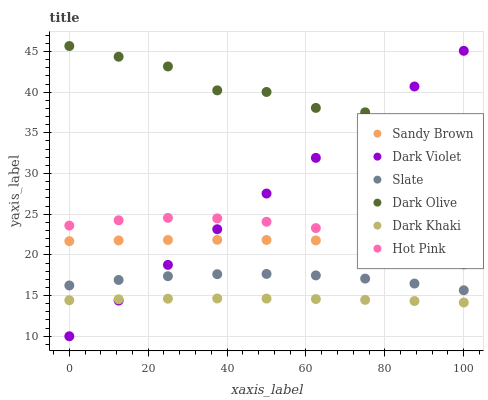Does Dark Khaki have the minimum area under the curve?
Answer yes or no. Yes. Does Dark Olive have the maximum area under the curve?
Answer yes or no. Yes. Does Slate have the minimum area under the curve?
Answer yes or no. No. Does Slate have the maximum area under the curve?
Answer yes or no. No. Is Dark Violet the smoothest?
Answer yes or no. Yes. Is Dark Olive the roughest?
Answer yes or no. Yes. Is Slate the smoothest?
Answer yes or no. No. Is Slate the roughest?
Answer yes or no. No. Does Dark Violet have the lowest value?
Answer yes or no. Yes. Does Slate have the lowest value?
Answer yes or no. No. Does Dark Olive have the highest value?
Answer yes or no. Yes. Does Slate have the highest value?
Answer yes or no. No. Is Hot Pink less than Dark Olive?
Answer yes or no. Yes. Is Slate greater than Dark Khaki?
Answer yes or no. Yes. Does Hot Pink intersect Sandy Brown?
Answer yes or no. Yes. Is Hot Pink less than Sandy Brown?
Answer yes or no. No. Is Hot Pink greater than Sandy Brown?
Answer yes or no. No. Does Hot Pink intersect Dark Olive?
Answer yes or no. No. 